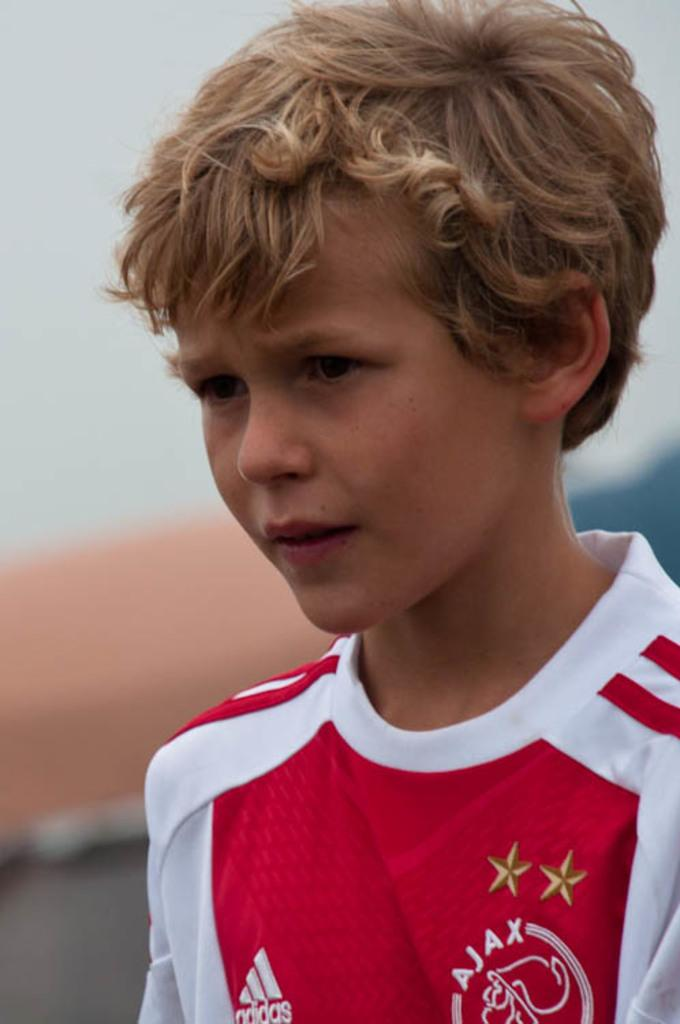Provide a one-sentence caption for the provided image. A young blonde boy with a red and white Adidas shirt. 